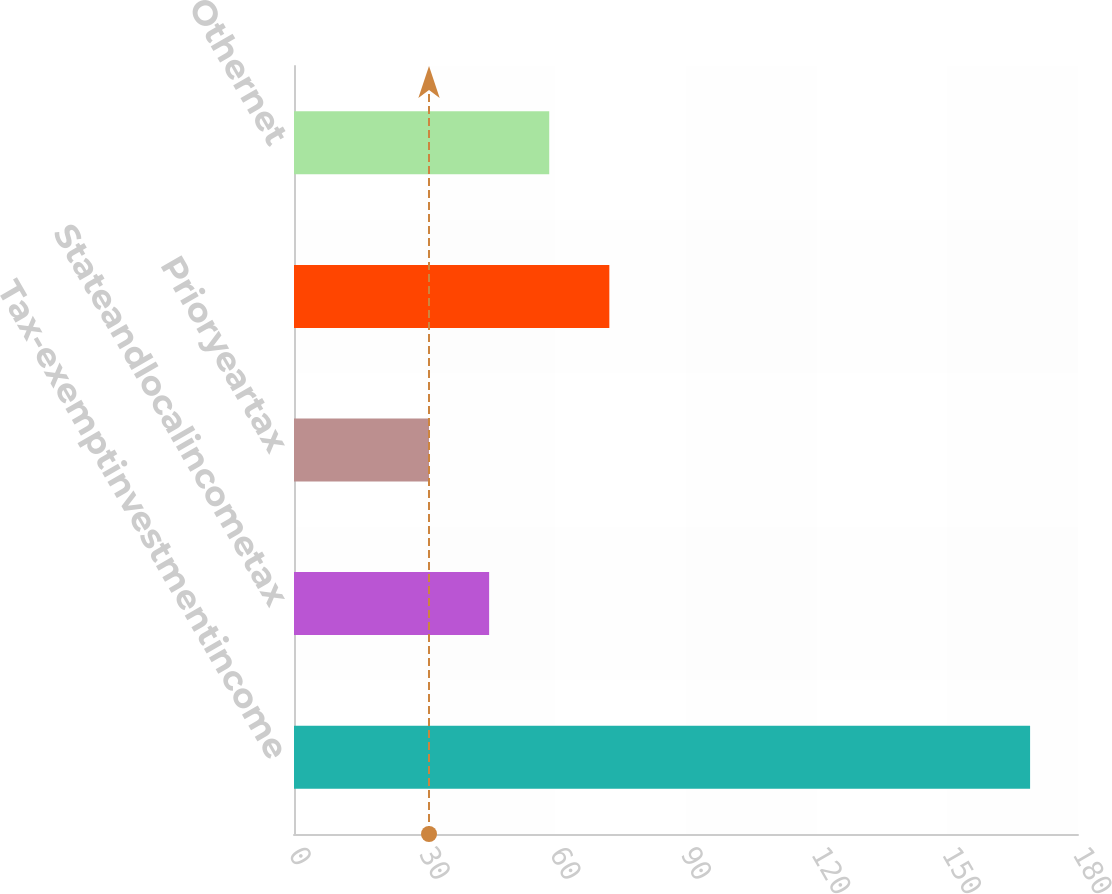Convert chart. <chart><loc_0><loc_0><loc_500><loc_500><bar_chart><fcel>Tax-exemptinvestmentincome<fcel>Stateandlocalincometax<fcel>Prioryeartax<fcel>Unnamed: 3<fcel>Othernet<nl><fcel>169<fcel>44.8<fcel>31<fcel>72.4<fcel>58.6<nl></chart> 